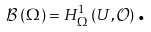<formula> <loc_0><loc_0><loc_500><loc_500>\mathcal { B } \left ( \Omega \right ) = H _ { \Omega } ^ { 1 } \left ( U , \mathcal { O } \right ) \text {.}</formula> 